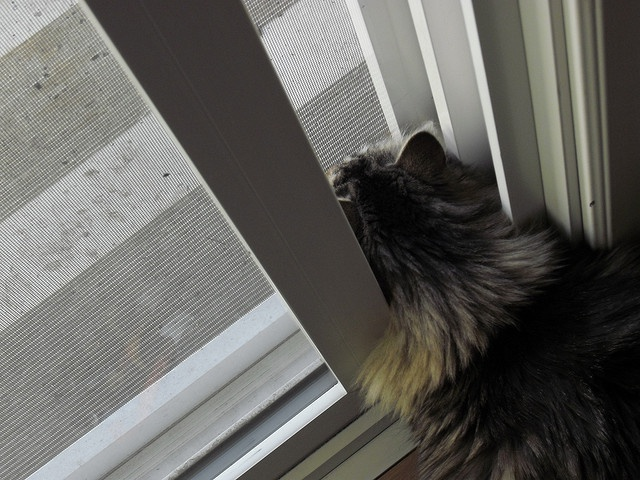Describe the objects in this image and their specific colors. I can see a cat in darkgray, black, and gray tones in this image. 